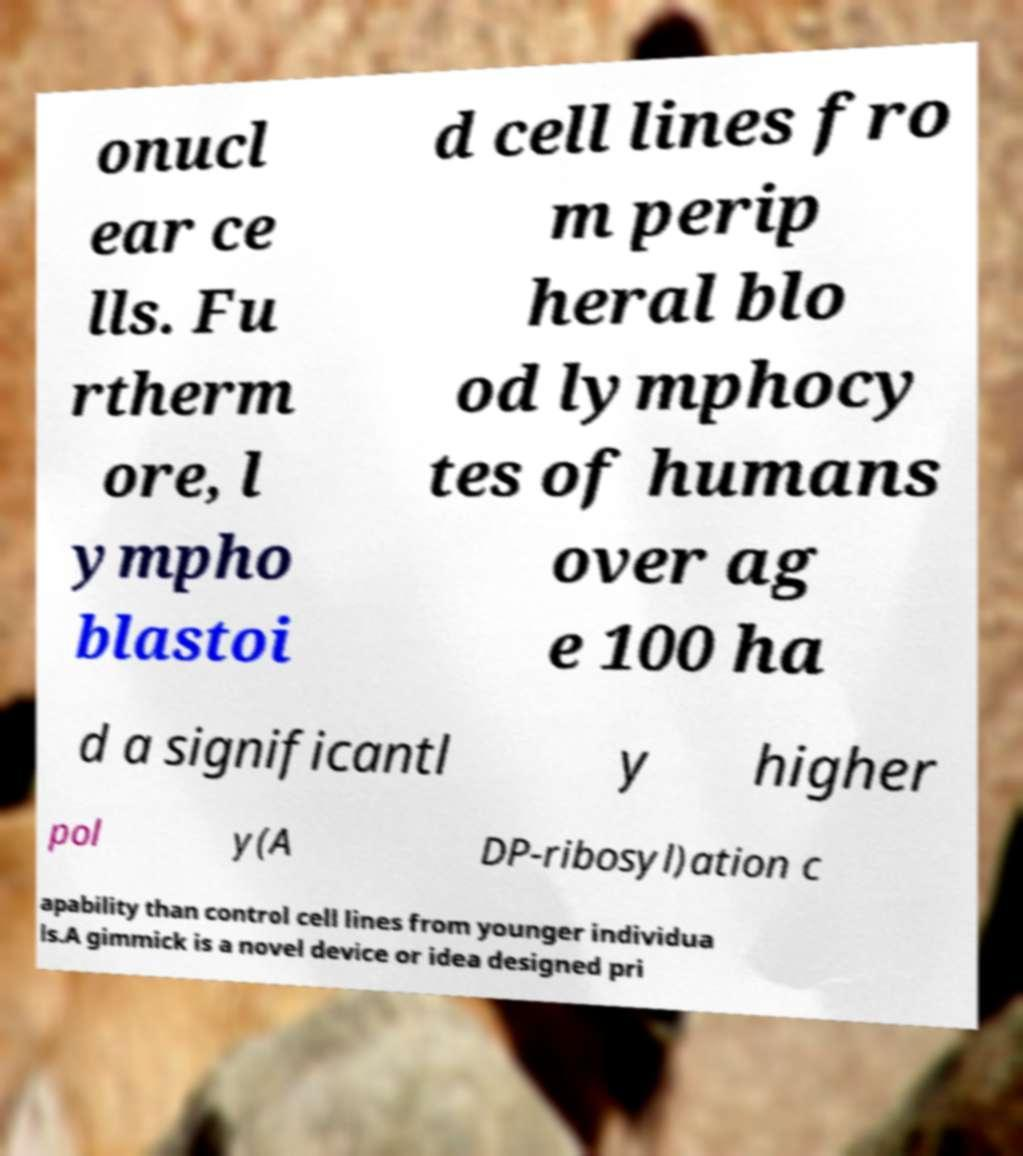I need the written content from this picture converted into text. Can you do that? onucl ear ce lls. Fu rtherm ore, l ympho blastoi d cell lines fro m perip heral blo od lymphocy tes of humans over ag e 100 ha d a significantl y higher pol y(A DP-ribosyl)ation c apability than control cell lines from younger individua ls.A gimmick is a novel device or idea designed pri 